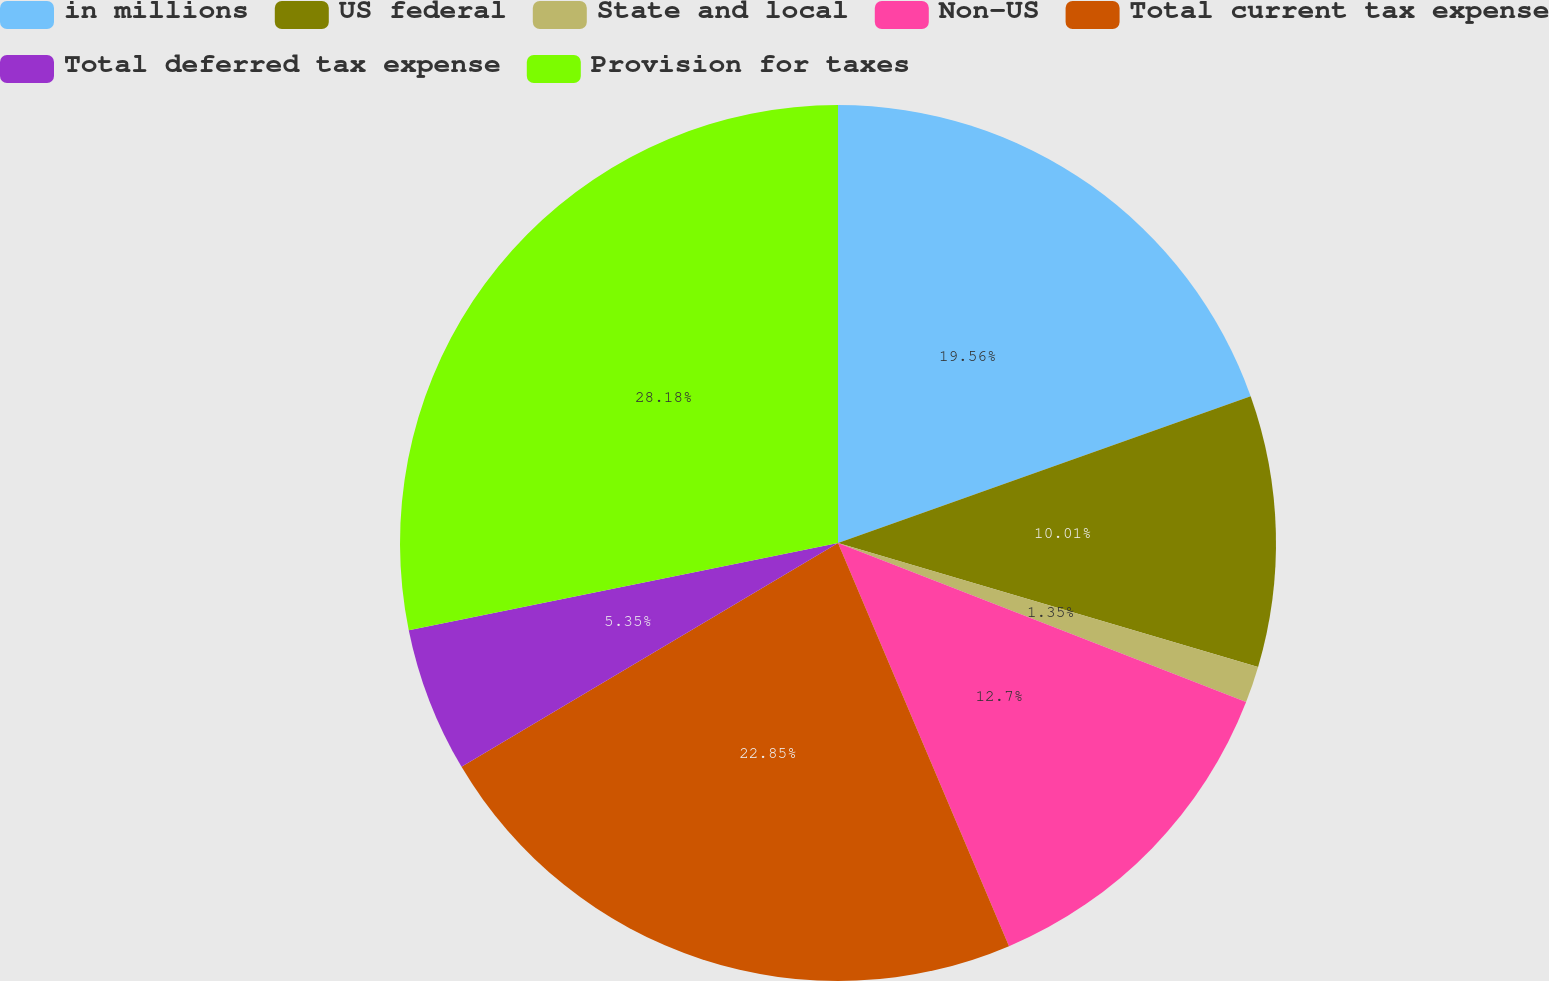Convert chart. <chart><loc_0><loc_0><loc_500><loc_500><pie_chart><fcel>in millions<fcel>US federal<fcel>State and local<fcel>Non-US<fcel>Total current tax expense<fcel>Total deferred tax expense<fcel>Provision for taxes<nl><fcel>19.56%<fcel>10.01%<fcel>1.35%<fcel>12.7%<fcel>22.85%<fcel>5.35%<fcel>28.19%<nl></chart> 